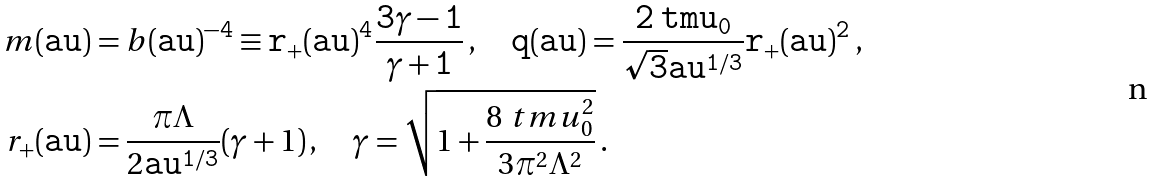<formula> <loc_0><loc_0><loc_500><loc_500>m ( \tt a u ) & = b ( \tt a u ) ^ { - 4 } \equiv r _ { + } ( \tt a u ) ^ { 4 } \frac { 3 \gamma - 1 } { \gamma + 1 } \, , \quad q ( \tt a u ) = \frac { 2 \ t m u _ { 0 } } { \sqrt { 3 } \tt a u ^ { 1 / 3 } } r _ { + } ( \tt a u ) ^ { 2 } \, , \\ r _ { + } ( \tt a u ) & = \frac { \pi \Lambda } { 2 \tt a u ^ { 1 / 3 } } ( \gamma + 1 ) \, , \quad \gamma = \sqrt { 1 + \frac { 8 \ t m u _ { 0 } ^ { 2 } } { 3 \pi ^ { 2 } \Lambda ^ { 2 } } } \, .</formula> 